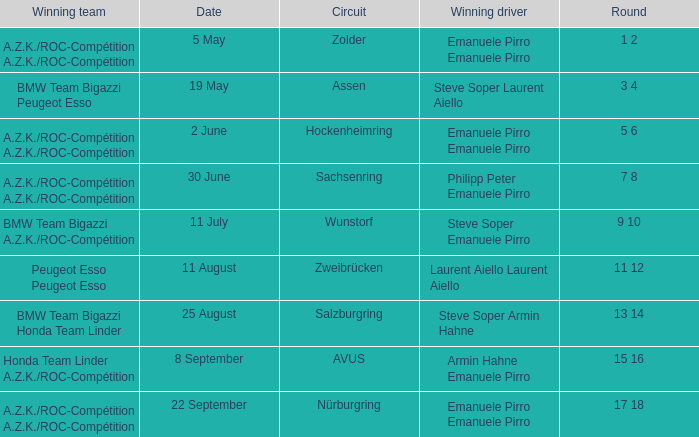What is the date of the zolder circuit, which had a.z.k./roc-compétition a.z.k./roc-compétition as the winning team? 5 May. 